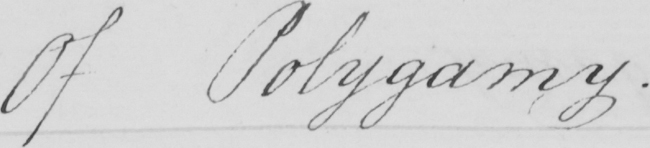Can you tell me what this handwritten text says? Of Polygamy . 